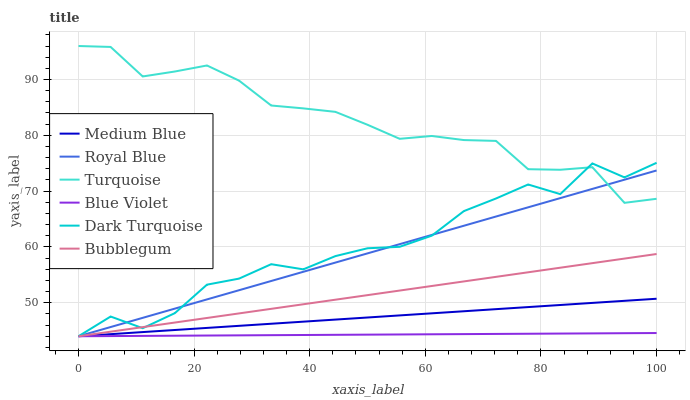Does Blue Violet have the minimum area under the curve?
Answer yes or no. Yes. Does Turquoise have the maximum area under the curve?
Answer yes or no. Yes. Does Dark Turquoise have the minimum area under the curve?
Answer yes or no. No. Does Dark Turquoise have the maximum area under the curve?
Answer yes or no. No. Is Medium Blue the smoothest?
Answer yes or no. Yes. Is Dark Turquoise the roughest?
Answer yes or no. Yes. Is Dark Turquoise the smoothest?
Answer yes or no. No. Is Medium Blue the roughest?
Answer yes or no. No. Does Dark Turquoise have the lowest value?
Answer yes or no. Yes. Does Turquoise have the highest value?
Answer yes or no. Yes. Does Dark Turquoise have the highest value?
Answer yes or no. No. Is Blue Violet less than Turquoise?
Answer yes or no. Yes. Is Turquoise greater than Blue Violet?
Answer yes or no. Yes. Does Royal Blue intersect Blue Violet?
Answer yes or no. Yes. Is Royal Blue less than Blue Violet?
Answer yes or no. No. Is Royal Blue greater than Blue Violet?
Answer yes or no. No. Does Blue Violet intersect Turquoise?
Answer yes or no. No. 